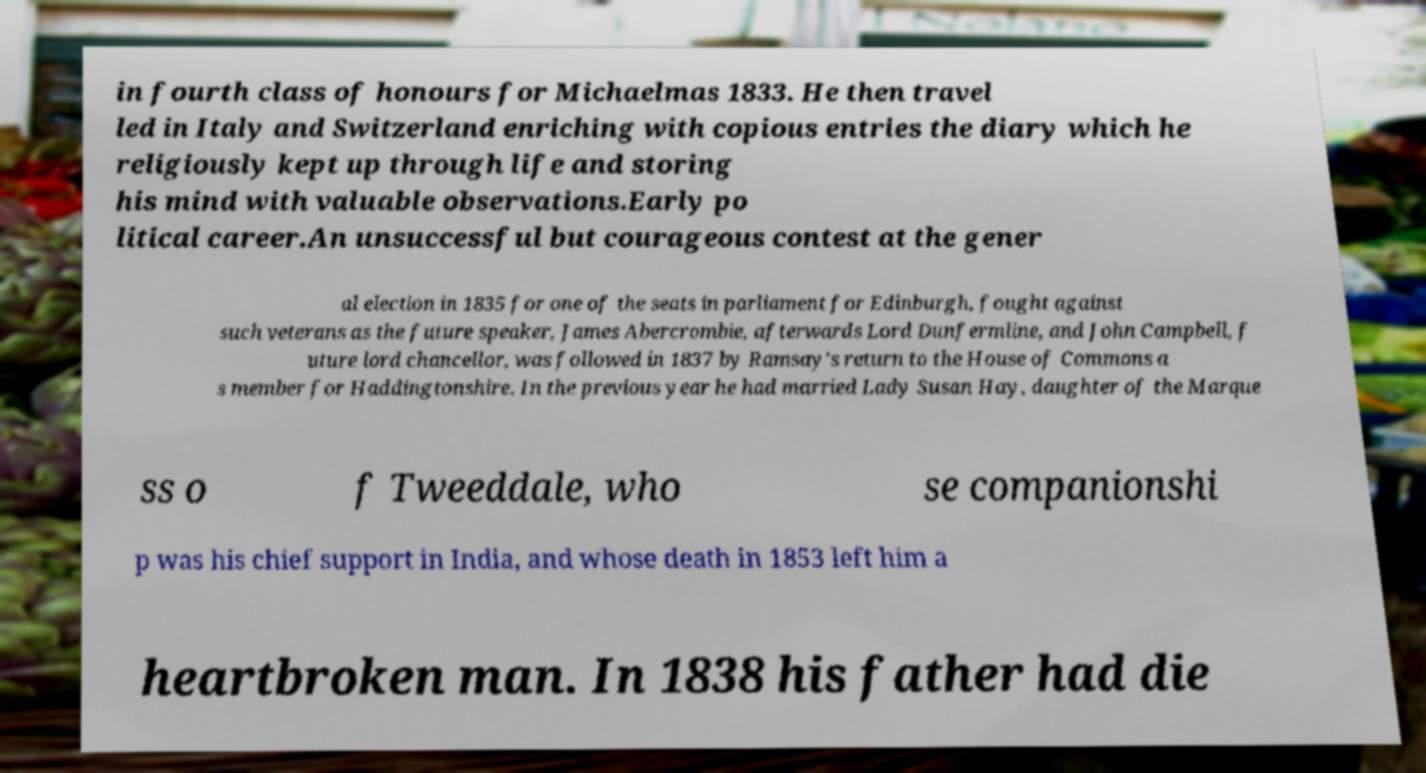Can you read and provide the text displayed in the image?This photo seems to have some interesting text. Can you extract and type it out for me? in fourth class of honours for Michaelmas 1833. He then travel led in Italy and Switzerland enriching with copious entries the diary which he religiously kept up through life and storing his mind with valuable observations.Early po litical career.An unsuccessful but courageous contest at the gener al election in 1835 for one of the seats in parliament for Edinburgh, fought against such veterans as the future speaker, James Abercrombie, afterwards Lord Dunfermline, and John Campbell, f uture lord chancellor, was followed in 1837 by Ramsay's return to the House of Commons a s member for Haddingtonshire. In the previous year he had married Lady Susan Hay, daughter of the Marque ss o f Tweeddale, who se companionshi p was his chief support in India, and whose death in 1853 left him a heartbroken man. In 1838 his father had die 